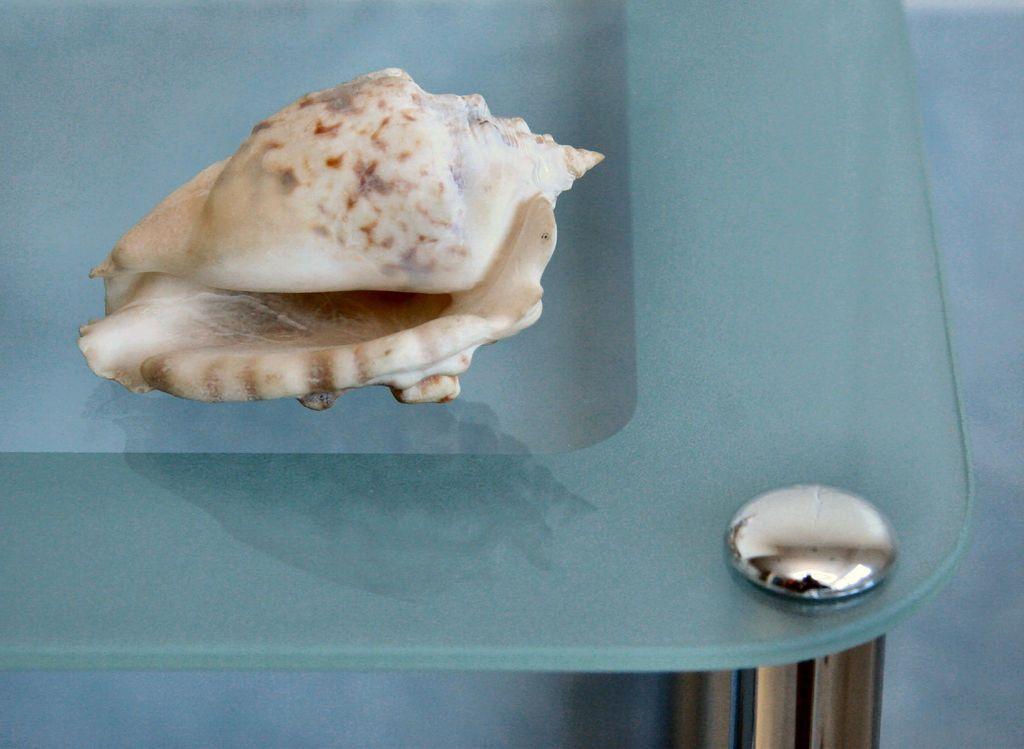Can you describe this image briefly? In the image we can see there is a sea shell kept on the glass table. 